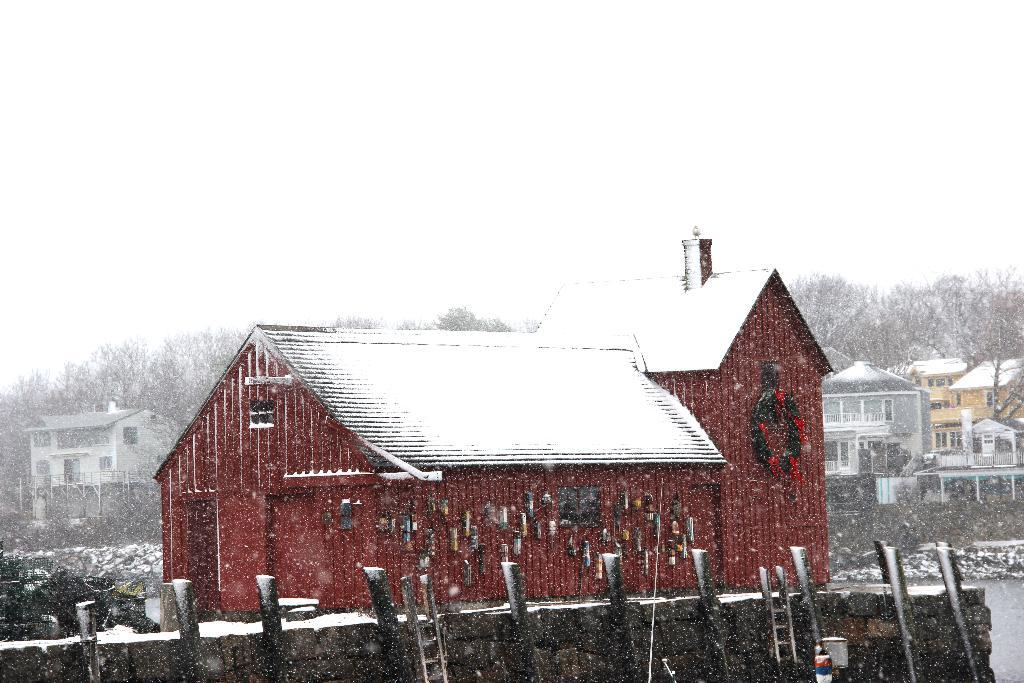What type of structures can be seen in the image? There are buildings in the image. What natural elements are present in the image? There are trees in the image. What equipment is visible in the image? There are ladders in the image. What weather condition is depicted in the image? There is snow visible in the image. What can be seen in the bottom right corner of the image? There appears to be water in the bottom right corner of the image. What is visible in the background of the image? The sky is visible in the image. Where is the mailbox located in the image? There is no mailbox present in the image. What type of tub is visible in the image? There is no tub present in the image. 